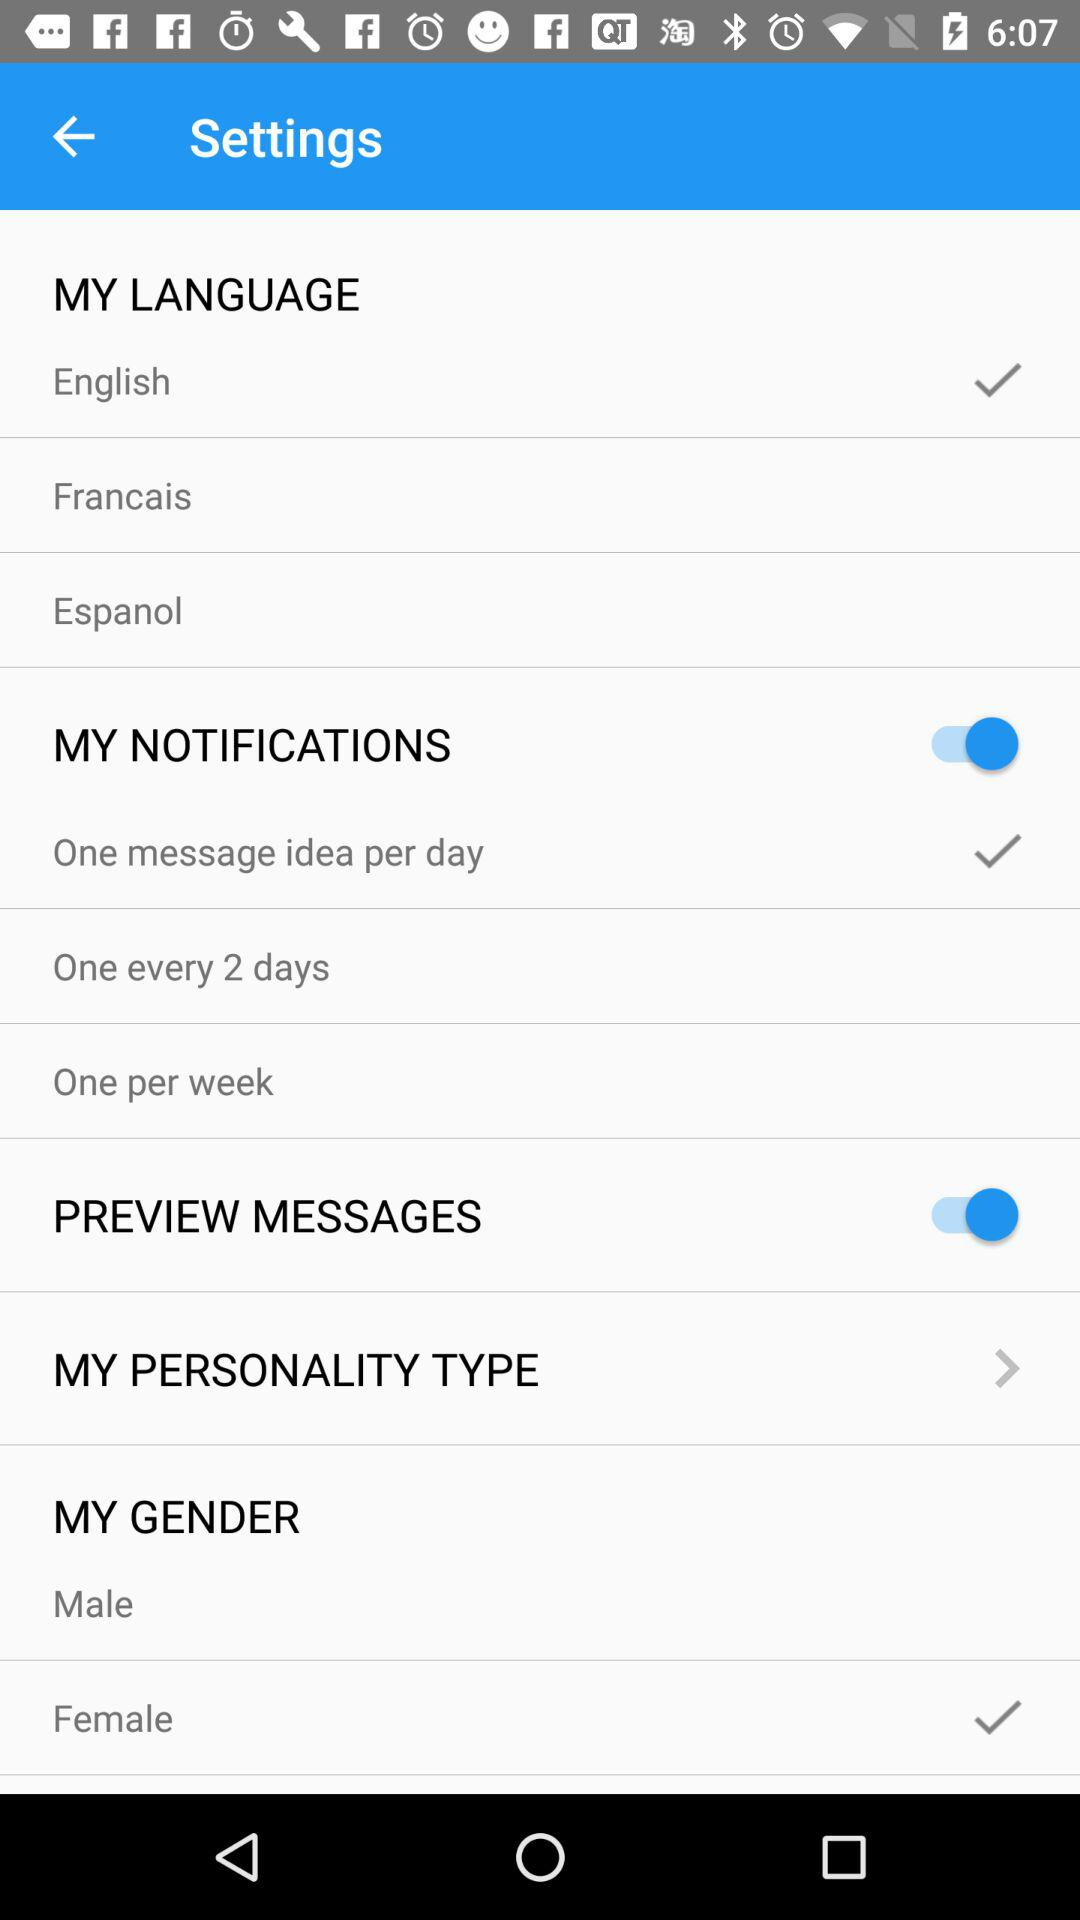Which gender is selected? The selected gender is female. 